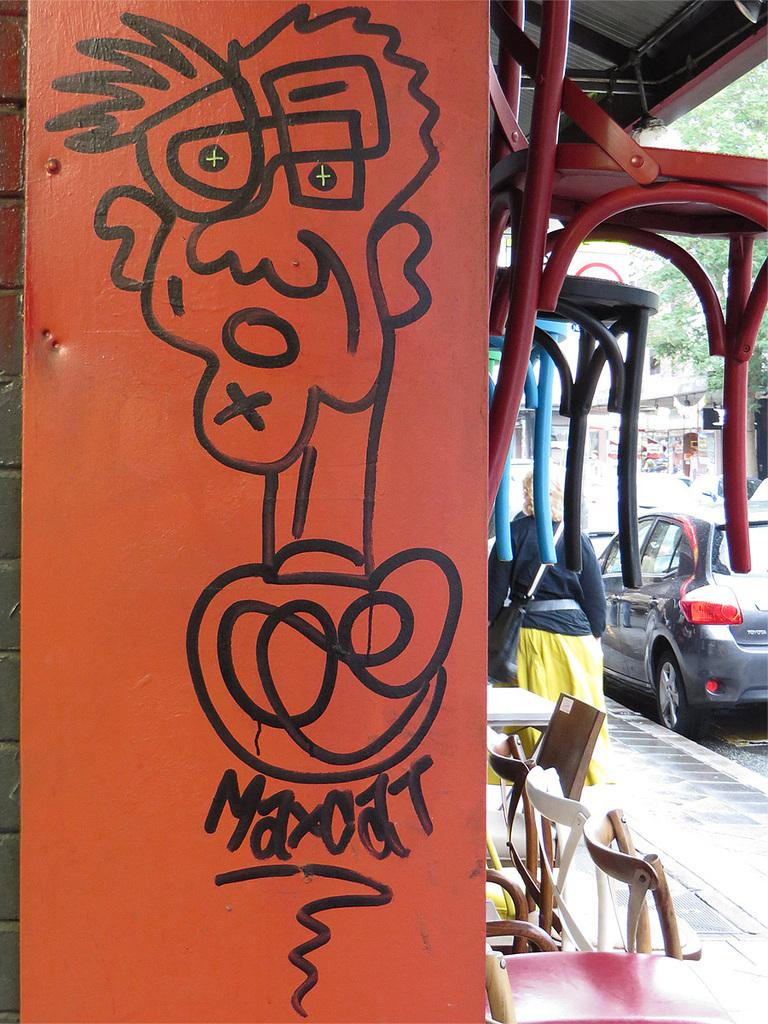Who is present in the image? There is a woman in the image. Where is the woman standing? The woman is standing on a footpath. What else can be seen on the road in the image? There is a car parked on the road in the image. What is depicted in front of the car? There is a drawing of a man in front of the car. What type of beef is being served at the restaurant in the image? There is no restaurant or beef present in the image; it features a woman standing on a footpath, a parked car, and a drawing of a man. 